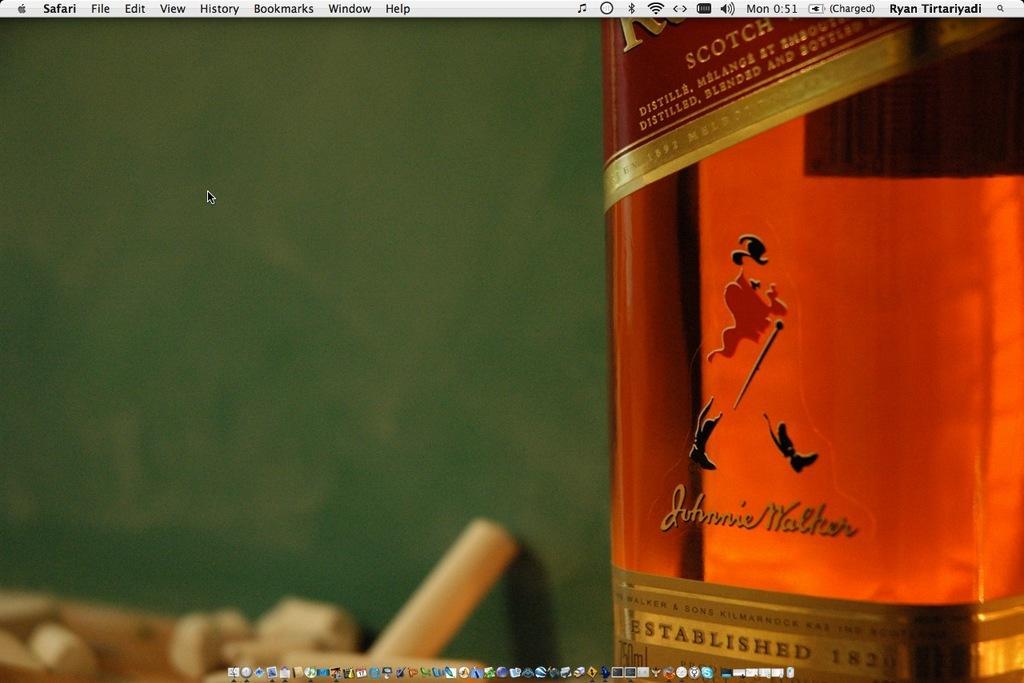Can you describe this image briefly? In this image we can see the wine bottle. And we can see the green colored background. 